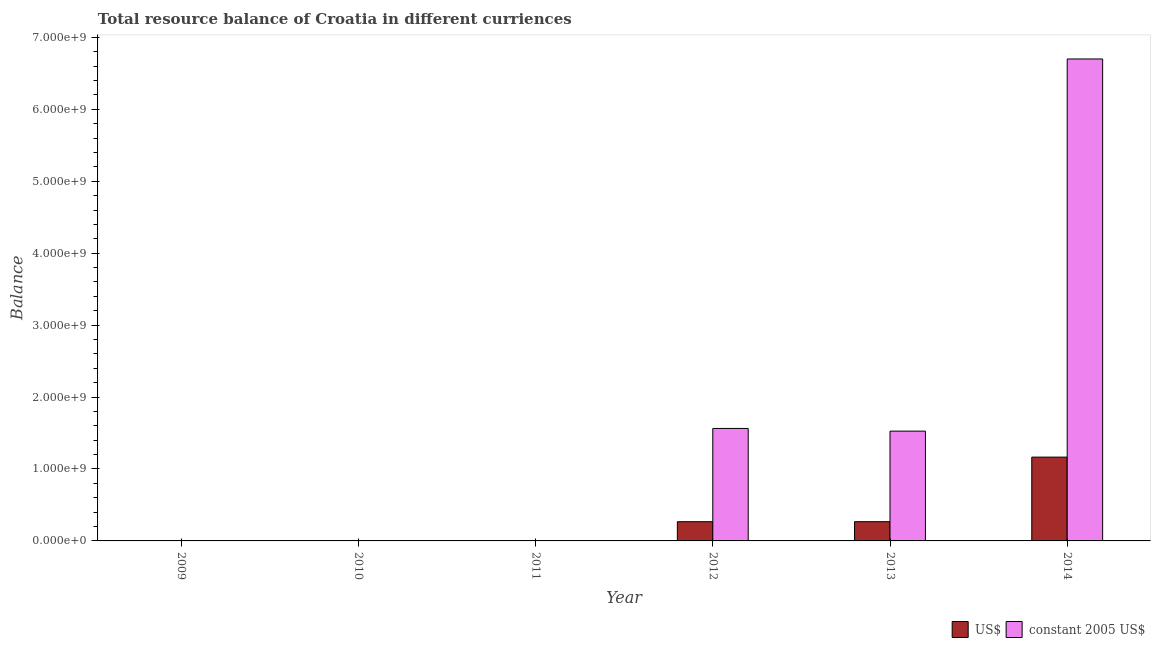Are the number of bars per tick equal to the number of legend labels?
Provide a succinct answer. No. How many bars are there on the 4th tick from the left?
Offer a very short reply. 2. In how many cases, is the number of bars for a given year not equal to the number of legend labels?
Make the answer very short. 3. What is the resource balance in constant us$ in 2013?
Your answer should be very brief. 1.53e+09. Across all years, what is the maximum resource balance in us$?
Provide a succinct answer. 1.17e+09. What is the total resource balance in us$ in the graph?
Offer a very short reply. 1.70e+09. What is the difference between the resource balance in constant us$ in 2013 and that in 2014?
Your answer should be very brief. -5.17e+09. What is the average resource balance in us$ per year?
Provide a succinct answer. 2.83e+08. What is the ratio of the resource balance in constant us$ in 2012 to that in 2013?
Give a very brief answer. 1.02. Is the resource balance in us$ in 2013 less than that in 2014?
Give a very brief answer. Yes. What is the difference between the highest and the second highest resource balance in constant us$?
Your answer should be very brief. 5.14e+09. What is the difference between the highest and the lowest resource balance in constant us$?
Ensure brevity in your answer.  6.70e+09. In how many years, is the resource balance in us$ greater than the average resource balance in us$ taken over all years?
Keep it short and to the point. 1. Are all the bars in the graph horizontal?
Provide a succinct answer. No. What is the difference between two consecutive major ticks on the Y-axis?
Make the answer very short. 1.00e+09. Where does the legend appear in the graph?
Your response must be concise. Bottom right. How many legend labels are there?
Make the answer very short. 2. How are the legend labels stacked?
Your answer should be compact. Horizontal. What is the title of the graph?
Ensure brevity in your answer.  Total resource balance of Croatia in different curriences. Does "External balance on goods" appear as one of the legend labels in the graph?
Keep it short and to the point. No. What is the label or title of the X-axis?
Your answer should be compact. Year. What is the label or title of the Y-axis?
Your answer should be very brief. Balance. What is the Balance in US$ in 2009?
Ensure brevity in your answer.  0. What is the Balance in constant 2005 US$ in 2009?
Provide a succinct answer. 0. What is the Balance in US$ in 2010?
Your answer should be very brief. 0. What is the Balance of constant 2005 US$ in 2010?
Keep it short and to the point. 0. What is the Balance of US$ in 2012?
Keep it short and to the point. 2.67e+08. What is the Balance in constant 2005 US$ in 2012?
Offer a terse response. 1.56e+09. What is the Balance of US$ in 2013?
Your response must be concise. 2.68e+08. What is the Balance of constant 2005 US$ in 2013?
Offer a terse response. 1.53e+09. What is the Balance of US$ in 2014?
Offer a very short reply. 1.17e+09. What is the Balance in constant 2005 US$ in 2014?
Provide a succinct answer. 6.70e+09. Across all years, what is the maximum Balance of US$?
Provide a short and direct response. 1.17e+09. Across all years, what is the maximum Balance of constant 2005 US$?
Offer a terse response. 6.70e+09. Across all years, what is the minimum Balance in US$?
Provide a succinct answer. 0. What is the total Balance in US$ in the graph?
Your answer should be very brief. 1.70e+09. What is the total Balance of constant 2005 US$ in the graph?
Offer a very short reply. 9.79e+09. What is the difference between the Balance of US$ in 2012 and that in 2013?
Your response must be concise. -2.68e+05. What is the difference between the Balance of constant 2005 US$ in 2012 and that in 2013?
Provide a succinct answer. 3.74e+07. What is the difference between the Balance of US$ in 2012 and that in 2014?
Provide a succinct answer. -8.98e+08. What is the difference between the Balance of constant 2005 US$ in 2012 and that in 2014?
Your answer should be very brief. -5.14e+09. What is the difference between the Balance in US$ in 2013 and that in 2014?
Keep it short and to the point. -8.98e+08. What is the difference between the Balance of constant 2005 US$ in 2013 and that in 2014?
Make the answer very short. -5.17e+09. What is the difference between the Balance in US$ in 2012 and the Balance in constant 2005 US$ in 2013?
Offer a terse response. -1.26e+09. What is the difference between the Balance in US$ in 2012 and the Balance in constant 2005 US$ in 2014?
Offer a terse response. -6.43e+09. What is the difference between the Balance of US$ in 2013 and the Balance of constant 2005 US$ in 2014?
Provide a succinct answer. -6.43e+09. What is the average Balance of US$ per year?
Give a very brief answer. 2.83e+08. What is the average Balance of constant 2005 US$ per year?
Your answer should be compact. 1.63e+09. In the year 2012, what is the difference between the Balance of US$ and Balance of constant 2005 US$?
Ensure brevity in your answer.  -1.30e+09. In the year 2013, what is the difference between the Balance of US$ and Balance of constant 2005 US$?
Offer a terse response. -1.26e+09. In the year 2014, what is the difference between the Balance in US$ and Balance in constant 2005 US$?
Offer a very short reply. -5.53e+09. What is the ratio of the Balance of constant 2005 US$ in 2012 to that in 2013?
Keep it short and to the point. 1.02. What is the ratio of the Balance in US$ in 2012 to that in 2014?
Your answer should be very brief. 0.23. What is the ratio of the Balance of constant 2005 US$ in 2012 to that in 2014?
Ensure brevity in your answer.  0.23. What is the ratio of the Balance of US$ in 2013 to that in 2014?
Provide a succinct answer. 0.23. What is the ratio of the Balance in constant 2005 US$ in 2013 to that in 2014?
Your response must be concise. 0.23. What is the difference between the highest and the second highest Balance of US$?
Offer a terse response. 8.98e+08. What is the difference between the highest and the second highest Balance of constant 2005 US$?
Give a very brief answer. 5.14e+09. What is the difference between the highest and the lowest Balance of US$?
Provide a succinct answer. 1.17e+09. What is the difference between the highest and the lowest Balance of constant 2005 US$?
Your answer should be very brief. 6.70e+09. 